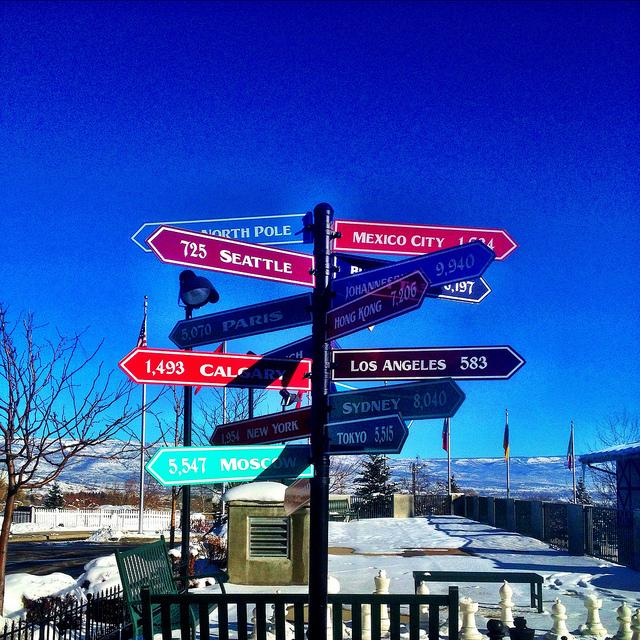What kind of locations are mentioned in the signs?

Choices:
A) continents
B) countries
C) cities
D) cardinal points cities 